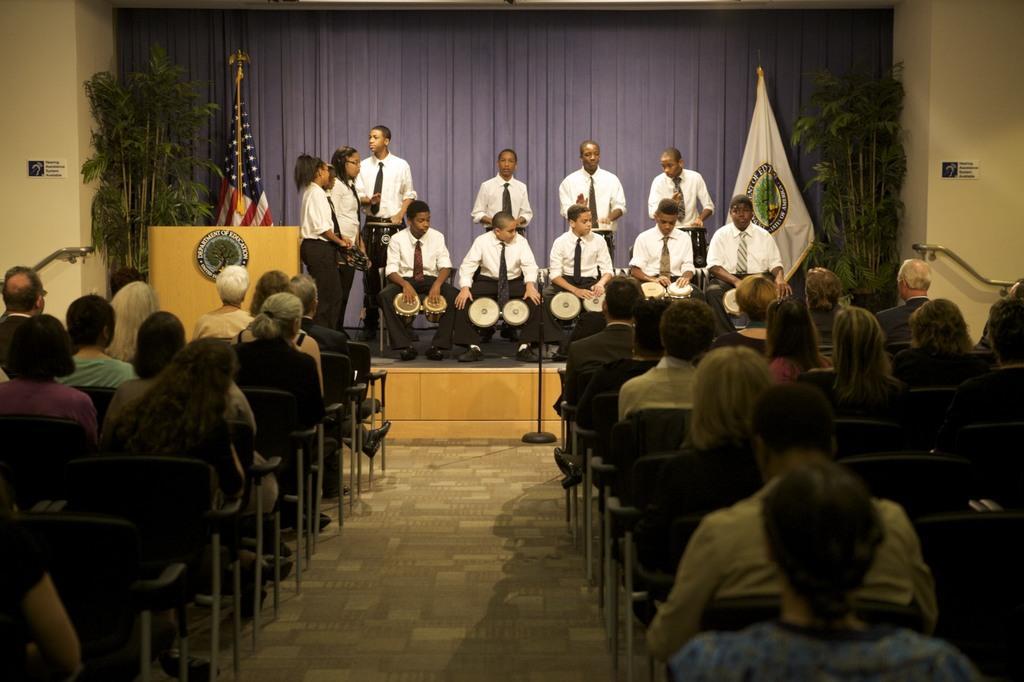Describe this image in one or two sentences. In the image we can see there are kids sitting on the stage and they are playing drums. There are other kids standing on the stage and there are flags kept behind. There are spectators sitting on the chair and watching them. 